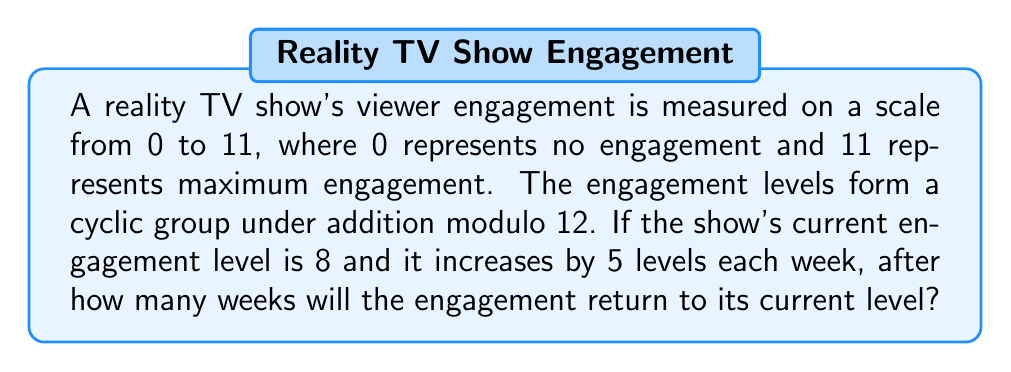Can you answer this question? Let's approach this step-by-step:

1) First, we need to understand that we're working with a cyclic group of order 12 (since we're using addition modulo 12). We can represent this group as:

   $$\mathbb{Z}_{12} = \{0, 1, 2, 3, 4, 5, 6, 7, 8, 9, 10, 11\}$$

2) The current engagement level is 8, and it increases by 5 each week. We need to find the smallest positive integer $n$ such that:

   $$(8 + 5n) \equiv 8 \pmod{12}$$

3) This is equivalent to solving:

   $$5n \equiv 0 \pmod{12}$$

4) To solve this, we need to find the order of 5 in $\mathbb{Z}_{12}$. Let's compute the multiples of 5 modulo 12:

   $5 \cdot 1 \equiv 5 \pmod{12}$
   $5 \cdot 2 \equiv 10 \pmod{12}$
   $5 \cdot 3 \equiv 3 \pmod{12}$
   $5 \cdot 4 \equiv 8 \pmod{12}$
   $5 \cdot 5 \equiv 1 \pmod{12}$
   $5 \cdot 6 \equiv 6 \pmod{12}$
   $5 \cdot 7 \equiv 11 \pmod{12}$
   $5 \cdot 8 \equiv 4 \pmod{12}$
   $5 \cdot 9 \equiv 9 \pmod{12}$
   $5 \cdot 10 \equiv 2 \pmod{12}$
   $5 \cdot 11 \equiv 7 \pmod{12}$
   $5 \cdot 12 \equiv 0 \pmod{12}$

5) We see that $5 \cdot 12 \equiv 0 \pmod{12}$, and this is the smallest positive integer that gives us 0.

6) Therefore, the order of 5 in $\mathbb{Z}_{12}$ is 12, which means it will take 12 weeks for the engagement to return to its current level.
Answer: 12 weeks 